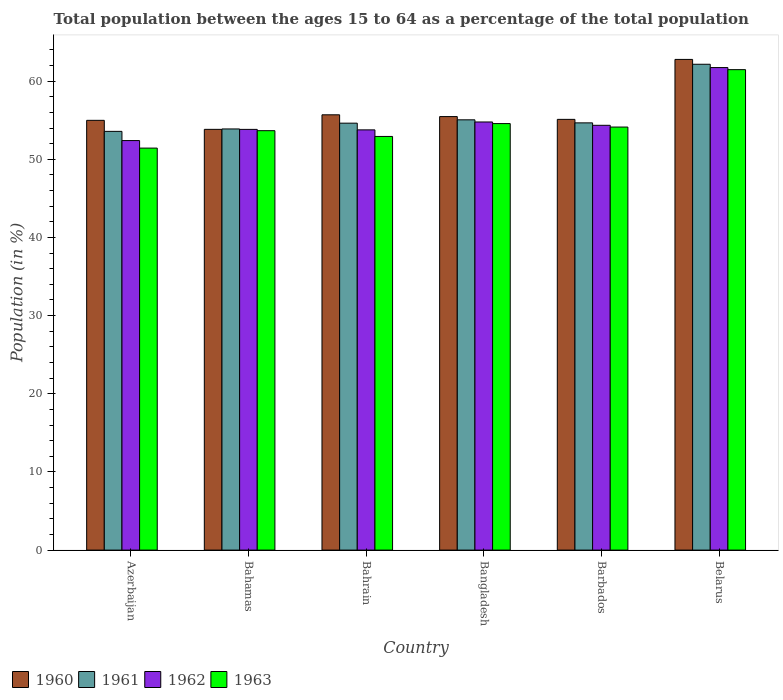How many different coloured bars are there?
Keep it short and to the point. 4. How many groups of bars are there?
Your answer should be compact. 6. How many bars are there on the 5th tick from the right?
Provide a short and direct response. 4. What is the label of the 6th group of bars from the left?
Ensure brevity in your answer.  Belarus. In how many cases, is the number of bars for a given country not equal to the number of legend labels?
Provide a short and direct response. 0. What is the percentage of the population ages 15 to 64 in 1963 in Bahrain?
Give a very brief answer. 52.92. Across all countries, what is the maximum percentage of the population ages 15 to 64 in 1960?
Ensure brevity in your answer.  62.78. Across all countries, what is the minimum percentage of the population ages 15 to 64 in 1962?
Offer a very short reply. 52.4. In which country was the percentage of the population ages 15 to 64 in 1960 maximum?
Offer a very short reply. Belarus. In which country was the percentage of the population ages 15 to 64 in 1960 minimum?
Offer a very short reply. Bahamas. What is the total percentage of the population ages 15 to 64 in 1960 in the graph?
Your response must be concise. 337.86. What is the difference between the percentage of the population ages 15 to 64 in 1962 in Bangladesh and that in Barbados?
Keep it short and to the point. 0.43. What is the difference between the percentage of the population ages 15 to 64 in 1960 in Belarus and the percentage of the population ages 15 to 64 in 1961 in Azerbaijan?
Your response must be concise. 9.21. What is the average percentage of the population ages 15 to 64 in 1962 per country?
Give a very brief answer. 55.14. What is the difference between the percentage of the population ages 15 to 64 of/in 1962 and percentage of the population ages 15 to 64 of/in 1961 in Belarus?
Your response must be concise. -0.42. In how many countries, is the percentage of the population ages 15 to 64 in 1961 greater than 40?
Ensure brevity in your answer.  6. What is the ratio of the percentage of the population ages 15 to 64 in 1961 in Azerbaijan to that in Belarus?
Offer a terse response. 0.86. Is the percentage of the population ages 15 to 64 in 1963 in Bahrain less than that in Belarus?
Your answer should be compact. Yes. Is the difference between the percentage of the population ages 15 to 64 in 1962 in Bahamas and Bahrain greater than the difference between the percentage of the population ages 15 to 64 in 1961 in Bahamas and Bahrain?
Ensure brevity in your answer.  Yes. What is the difference between the highest and the second highest percentage of the population ages 15 to 64 in 1962?
Your answer should be very brief. -7.39. What is the difference between the highest and the lowest percentage of the population ages 15 to 64 in 1963?
Ensure brevity in your answer.  10.04. Is the sum of the percentage of the population ages 15 to 64 in 1960 in Azerbaijan and Bahamas greater than the maximum percentage of the population ages 15 to 64 in 1963 across all countries?
Make the answer very short. Yes. Is it the case that in every country, the sum of the percentage of the population ages 15 to 64 in 1960 and percentage of the population ages 15 to 64 in 1963 is greater than the sum of percentage of the population ages 15 to 64 in 1962 and percentage of the population ages 15 to 64 in 1961?
Offer a very short reply. No. How many bars are there?
Your response must be concise. 24. What is the difference between two consecutive major ticks on the Y-axis?
Make the answer very short. 10. Does the graph contain any zero values?
Offer a terse response. No. How many legend labels are there?
Your response must be concise. 4. What is the title of the graph?
Your answer should be compact. Total population between the ages 15 to 64 as a percentage of the total population. Does "1989" appear as one of the legend labels in the graph?
Your answer should be very brief. No. What is the Population (in %) of 1960 in Azerbaijan?
Make the answer very short. 54.98. What is the Population (in %) in 1961 in Azerbaijan?
Offer a very short reply. 53.57. What is the Population (in %) of 1962 in Azerbaijan?
Give a very brief answer. 52.4. What is the Population (in %) of 1963 in Azerbaijan?
Provide a short and direct response. 51.43. What is the Population (in %) in 1960 in Bahamas?
Give a very brief answer. 53.83. What is the Population (in %) in 1961 in Bahamas?
Keep it short and to the point. 53.88. What is the Population (in %) in 1962 in Bahamas?
Provide a succinct answer. 53.83. What is the Population (in %) of 1963 in Bahamas?
Provide a short and direct response. 53.66. What is the Population (in %) in 1960 in Bahrain?
Offer a terse response. 55.69. What is the Population (in %) in 1961 in Bahrain?
Your answer should be very brief. 54.62. What is the Population (in %) in 1962 in Bahrain?
Make the answer very short. 53.77. What is the Population (in %) of 1963 in Bahrain?
Provide a succinct answer. 52.92. What is the Population (in %) in 1960 in Bangladesh?
Ensure brevity in your answer.  55.46. What is the Population (in %) in 1961 in Bangladesh?
Provide a succinct answer. 55.05. What is the Population (in %) of 1962 in Bangladesh?
Your answer should be very brief. 54.78. What is the Population (in %) of 1963 in Bangladesh?
Ensure brevity in your answer.  54.57. What is the Population (in %) in 1960 in Barbados?
Offer a terse response. 55.11. What is the Population (in %) of 1961 in Barbados?
Offer a terse response. 54.66. What is the Population (in %) in 1962 in Barbados?
Offer a very short reply. 54.35. What is the Population (in %) in 1963 in Barbados?
Provide a succinct answer. 54.12. What is the Population (in %) in 1960 in Belarus?
Your answer should be very brief. 62.78. What is the Population (in %) in 1961 in Belarus?
Ensure brevity in your answer.  62.16. What is the Population (in %) of 1962 in Belarus?
Your answer should be compact. 61.74. What is the Population (in %) in 1963 in Belarus?
Provide a succinct answer. 61.47. Across all countries, what is the maximum Population (in %) of 1960?
Your response must be concise. 62.78. Across all countries, what is the maximum Population (in %) in 1961?
Offer a very short reply. 62.16. Across all countries, what is the maximum Population (in %) in 1962?
Provide a short and direct response. 61.74. Across all countries, what is the maximum Population (in %) in 1963?
Make the answer very short. 61.47. Across all countries, what is the minimum Population (in %) of 1960?
Provide a succinct answer. 53.83. Across all countries, what is the minimum Population (in %) in 1961?
Offer a very short reply. 53.57. Across all countries, what is the minimum Population (in %) of 1962?
Offer a terse response. 52.4. Across all countries, what is the minimum Population (in %) of 1963?
Provide a succinct answer. 51.43. What is the total Population (in %) of 1960 in the graph?
Keep it short and to the point. 337.86. What is the total Population (in %) in 1961 in the graph?
Ensure brevity in your answer.  333.95. What is the total Population (in %) in 1962 in the graph?
Keep it short and to the point. 330.85. What is the total Population (in %) in 1963 in the graph?
Keep it short and to the point. 328.18. What is the difference between the Population (in %) of 1960 in Azerbaijan and that in Bahamas?
Give a very brief answer. 1.15. What is the difference between the Population (in %) of 1961 in Azerbaijan and that in Bahamas?
Provide a succinct answer. -0.31. What is the difference between the Population (in %) in 1962 in Azerbaijan and that in Bahamas?
Give a very brief answer. -1.43. What is the difference between the Population (in %) in 1963 in Azerbaijan and that in Bahamas?
Your answer should be compact. -2.23. What is the difference between the Population (in %) in 1960 in Azerbaijan and that in Bahrain?
Provide a short and direct response. -0.71. What is the difference between the Population (in %) of 1961 in Azerbaijan and that in Bahrain?
Ensure brevity in your answer.  -1.05. What is the difference between the Population (in %) in 1962 in Azerbaijan and that in Bahrain?
Your answer should be compact. -1.37. What is the difference between the Population (in %) in 1963 in Azerbaijan and that in Bahrain?
Keep it short and to the point. -1.49. What is the difference between the Population (in %) of 1960 in Azerbaijan and that in Bangladesh?
Your response must be concise. -0.48. What is the difference between the Population (in %) in 1961 in Azerbaijan and that in Bangladesh?
Make the answer very short. -1.48. What is the difference between the Population (in %) in 1962 in Azerbaijan and that in Bangladesh?
Give a very brief answer. -2.38. What is the difference between the Population (in %) of 1963 in Azerbaijan and that in Bangladesh?
Ensure brevity in your answer.  -3.14. What is the difference between the Population (in %) of 1960 in Azerbaijan and that in Barbados?
Ensure brevity in your answer.  -0.12. What is the difference between the Population (in %) in 1961 in Azerbaijan and that in Barbados?
Provide a short and direct response. -1.09. What is the difference between the Population (in %) of 1962 in Azerbaijan and that in Barbados?
Offer a terse response. -1.95. What is the difference between the Population (in %) of 1963 in Azerbaijan and that in Barbados?
Offer a very short reply. -2.69. What is the difference between the Population (in %) in 1960 in Azerbaijan and that in Belarus?
Provide a succinct answer. -7.79. What is the difference between the Population (in %) in 1961 in Azerbaijan and that in Belarus?
Provide a short and direct response. -8.59. What is the difference between the Population (in %) in 1962 in Azerbaijan and that in Belarus?
Your answer should be very brief. -9.34. What is the difference between the Population (in %) of 1963 in Azerbaijan and that in Belarus?
Offer a very short reply. -10.04. What is the difference between the Population (in %) of 1960 in Bahamas and that in Bahrain?
Give a very brief answer. -1.86. What is the difference between the Population (in %) in 1961 in Bahamas and that in Bahrain?
Keep it short and to the point. -0.74. What is the difference between the Population (in %) of 1962 in Bahamas and that in Bahrain?
Your answer should be compact. 0.06. What is the difference between the Population (in %) of 1963 in Bahamas and that in Bahrain?
Your answer should be very brief. 0.74. What is the difference between the Population (in %) in 1960 in Bahamas and that in Bangladesh?
Provide a succinct answer. -1.63. What is the difference between the Population (in %) of 1961 in Bahamas and that in Bangladesh?
Your response must be concise. -1.17. What is the difference between the Population (in %) in 1962 in Bahamas and that in Bangladesh?
Your answer should be compact. -0.95. What is the difference between the Population (in %) of 1963 in Bahamas and that in Bangladesh?
Your answer should be compact. -0.91. What is the difference between the Population (in %) in 1960 in Bahamas and that in Barbados?
Keep it short and to the point. -1.28. What is the difference between the Population (in %) in 1961 in Bahamas and that in Barbados?
Ensure brevity in your answer.  -0.78. What is the difference between the Population (in %) of 1962 in Bahamas and that in Barbados?
Keep it short and to the point. -0.52. What is the difference between the Population (in %) in 1963 in Bahamas and that in Barbados?
Keep it short and to the point. -0.46. What is the difference between the Population (in %) in 1960 in Bahamas and that in Belarus?
Keep it short and to the point. -8.95. What is the difference between the Population (in %) of 1961 in Bahamas and that in Belarus?
Provide a succinct answer. -8.28. What is the difference between the Population (in %) in 1962 in Bahamas and that in Belarus?
Provide a short and direct response. -7.91. What is the difference between the Population (in %) of 1963 in Bahamas and that in Belarus?
Your answer should be compact. -7.81. What is the difference between the Population (in %) of 1960 in Bahrain and that in Bangladesh?
Make the answer very short. 0.23. What is the difference between the Population (in %) in 1961 in Bahrain and that in Bangladesh?
Keep it short and to the point. -0.43. What is the difference between the Population (in %) in 1962 in Bahrain and that in Bangladesh?
Offer a very short reply. -1.01. What is the difference between the Population (in %) in 1963 in Bahrain and that in Bangladesh?
Offer a very short reply. -1.65. What is the difference between the Population (in %) in 1960 in Bahrain and that in Barbados?
Offer a very short reply. 0.58. What is the difference between the Population (in %) of 1961 in Bahrain and that in Barbados?
Ensure brevity in your answer.  -0.04. What is the difference between the Population (in %) in 1962 in Bahrain and that in Barbados?
Make the answer very short. -0.58. What is the difference between the Population (in %) of 1963 in Bahrain and that in Barbados?
Make the answer very short. -1.2. What is the difference between the Population (in %) in 1960 in Bahrain and that in Belarus?
Offer a very short reply. -7.09. What is the difference between the Population (in %) in 1961 in Bahrain and that in Belarus?
Give a very brief answer. -7.54. What is the difference between the Population (in %) of 1962 in Bahrain and that in Belarus?
Keep it short and to the point. -7.97. What is the difference between the Population (in %) in 1963 in Bahrain and that in Belarus?
Your response must be concise. -8.55. What is the difference between the Population (in %) in 1960 in Bangladesh and that in Barbados?
Your answer should be very brief. 0.36. What is the difference between the Population (in %) of 1961 in Bangladesh and that in Barbados?
Offer a very short reply. 0.39. What is the difference between the Population (in %) of 1962 in Bangladesh and that in Barbados?
Give a very brief answer. 0.43. What is the difference between the Population (in %) of 1963 in Bangladesh and that in Barbados?
Offer a terse response. 0.45. What is the difference between the Population (in %) of 1960 in Bangladesh and that in Belarus?
Offer a terse response. -7.32. What is the difference between the Population (in %) in 1961 in Bangladesh and that in Belarus?
Your answer should be very brief. -7.11. What is the difference between the Population (in %) in 1962 in Bangladesh and that in Belarus?
Your answer should be compact. -6.96. What is the difference between the Population (in %) of 1963 in Bangladesh and that in Belarus?
Your response must be concise. -6.9. What is the difference between the Population (in %) of 1960 in Barbados and that in Belarus?
Your answer should be compact. -7.67. What is the difference between the Population (in %) of 1961 in Barbados and that in Belarus?
Offer a terse response. -7.5. What is the difference between the Population (in %) in 1962 in Barbados and that in Belarus?
Offer a terse response. -7.39. What is the difference between the Population (in %) in 1963 in Barbados and that in Belarus?
Provide a succinct answer. -7.34. What is the difference between the Population (in %) in 1960 in Azerbaijan and the Population (in %) in 1961 in Bahamas?
Your answer should be very brief. 1.1. What is the difference between the Population (in %) of 1960 in Azerbaijan and the Population (in %) of 1962 in Bahamas?
Give a very brief answer. 1.16. What is the difference between the Population (in %) in 1960 in Azerbaijan and the Population (in %) in 1963 in Bahamas?
Your answer should be compact. 1.32. What is the difference between the Population (in %) of 1961 in Azerbaijan and the Population (in %) of 1962 in Bahamas?
Keep it short and to the point. -0.25. What is the difference between the Population (in %) in 1961 in Azerbaijan and the Population (in %) in 1963 in Bahamas?
Offer a very short reply. -0.09. What is the difference between the Population (in %) in 1962 in Azerbaijan and the Population (in %) in 1963 in Bahamas?
Your response must be concise. -1.27. What is the difference between the Population (in %) in 1960 in Azerbaijan and the Population (in %) in 1961 in Bahrain?
Your response must be concise. 0.36. What is the difference between the Population (in %) of 1960 in Azerbaijan and the Population (in %) of 1962 in Bahrain?
Offer a terse response. 1.22. What is the difference between the Population (in %) of 1960 in Azerbaijan and the Population (in %) of 1963 in Bahrain?
Offer a very short reply. 2.06. What is the difference between the Population (in %) of 1961 in Azerbaijan and the Population (in %) of 1962 in Bahrain?
Give a very brief answer. -0.19. What is the difference between the Population (in %) of 1961 in Azerbaijan and the Population (in %) of 1963 in Bahrain?
Your answer should be compact. 0.65. What is the difference between the Population (in %) in 1962 in Azerbaijan and the Population (in %) in 1963 in Bahrain?
Your response must be concise. -0.53. What is the difference between the Population (in %) in 1960 in Azerbaijan and the Population (in %) in 1961 in Bangladesh?
Keep it short and to the point. -0.07. What is the difference between the Population (in %) of 1960 in Azerbaijan and the Population (in %) of 1962 in Bangladesh?
Offer a terse response. 0.21. What is the difference between the Population (in %) in 1960 in Azerbaijan and the Population (in %) in 1963 in Bangladesh?
Your answer should be very brief. 0.41. What is the difference between the Population (in %) in 1961 in Azerbaijan and the Population (in %) in 1962 in Bangladesh?
Keep it short and to the point. -1.2. What is the difference between the Population (in %) in 1961 in Azerbaijan and the Population (in %) in 1963 in Bangladesh?
Ensure brevity in your answer.  -1. What is the difference between the Population (in %) in 1962 in Azerbaijan and the Population (in %) in 1963 in Bangladesh?
Your response must be concise. -2.17. What is the difference between the Population (in %) of 1960 in Azerbaijan and the Population (in %) of 1961 in Barbados?
Your answer should be very brief. 0.32. What is the difference between the Population (in %) in 1960 in Azerbaijan and the Population (in %) in 1962 in Barbados?
Your answer should be compact. 0.64. What is the difference between the Population (in %) of 1960 in Azerbaijan and the Population (in %) of 1963 in Barbados?
Your answer should be compact. 0.86. What is the difference between the Population (in %) in 1961 in Azerbaijan and the Population (in %) in 1962 in Barbados?
Offer a very short reply. -0.78. What is the difference between the Population (in %) in 1961 in Azerbaijan and the Population (in %) in 1963 in Barbados?
Provide a short and direct response. -0.55. What is the difference between the Population (in %) of 1962 in Azerbaijan and the Population (in %) of 1963 in Barbados?
Give a very brief answer. -1.73. What is the difference between the Population (in %) of 1960 in Azerbaijan and the Population (in %) of 1961 in Belarus?
Give a very brief answer. -7.17. What is the difference between the Population (in %) in 1960 in Azerbaijan and the Population (in %) in 1962 in Belarus?
Your answer should be compact. -6.75. What is the difference between the Population (in %) of 1960 in Azerbaijan and the Population (in %) of 1963 in Belarus?
Keep it short and to the point. -6.48. What is the difference between the Population (in %) in 1961 in Azerbaijan and the Population (in %) in 1962 in Belarus?
Provide a short and direct response. -8.16. What is the difference between the Population (in %) in 1961 in Azerbaijan and the Population (in %) in 1963 in Belarus?
Offer a very short reply. -7.9. What is the difference between the Population (in %) in 1962 in Azerbaijan and the Population (in %) in 1963 in Belarus?
Give a very brief answer. -9.07. What is the difference between the Population (in %) in 1960 in Bahamas and the Population (in %) in 1961 in Bahrain?
Provide a short and direct response. -0.79. What is the difference between the Population (in %) of 1960 in Bahamas and the Population (in %) of 1962 in Bahrain?
Give a very brief answer. 0.07. What is the difference between the Population (in %) of 1960 in Bahamas and the Population (in %) of 1963 in Bahrain?
Provide a short and direct response. 0.91. What is the difference between the Population (in %) of 1961 in Bahamas and the Population (in %) of 1962 in Bahrain?
Keep it short and to the point. 0.12. What is the difference between the Population (in %) in 1961 in Bahamas and the Population (in %) in 1963 in Bahrain?
Ensure brevity in your answer.  0.96. What is the difference between the Population (in %) in 1962 in Bahamas and the Population (in %) in 1963 in Bahrain?
Provide a succinct answer. 0.9. What is the difference between the Population (in %) in 1960 in Bahamas and the Population (in %) in 1961 in Bangladesh?
Your answer should be compact. -1.22. What is the difference between the Population (in %) in 1960 in Bahamas and the Population (in %) in 1962 in Bangladesh?
Your answer should be very brief. -0.94. What is the difference between the Population (in %) in 1960 in Bahamas and the Population (in %) in 1963 in Bangladesh?
Your response must be concise. -0.74. What is the difference between the Population (in %) of 1961 in Bahamas and the Population (in %) of 1962 in Bangladesh?
Make the answer very short. -0.89. What is the difference between the Population (in %) in 1961 in Bahamas and the Population (in %) in 1963 in Bangladesh?
Provide a short and direct response. -0.69. What is the difference between the Population (in %) of 1962 in Bahamas and the Population (in %) of 1963 in Bangladesh?
Offer a terse response. -0.74. What is the difference between the Population (in %) of 1960 in Bahamas and the Population (in %) of 1961 in Barbados?
Your answer should be very brief. -0.83. What is the difference between the Population (in %) of 1960 in Bahamas and the Population (in %) of 1962 in Barbados?
Provide a succinct answer. -0.52. What is the difference between the Population (in %) in 1960 in Bahamas and the Population (in %) in 1963 in Barbados?
Your answer should be compact. -0.29. What is the difference between the Population (in %) in 1961 in Bahamas and the Population (in %) in 1962 in Barbados?
Your answer should be compact. -0.46. What is the difference between the Population (in %) of 1961 in Bahamas and the Population (in %) of 1963 in Barbados?
Give a very brief answer. -0.24. What is the difference between the Population (in %) of 1962 in Bahamas and the Population (in %) of 1963 in Barbados?
Provide a succinct answer. -0.3. What is the difference between the Population (in %) in 1960 in Bahamas and the Population (in %) in 1961 in Belarus?
Your answer should be compact. -8.33. What is the difference between the Population (in %) of 1960 in Bahamas and the Population (in %) of 1962 in Belarus?
Offer a very short reply. -7.91. What is the difference between the Population (in %) in 1960 in Bahamas and the Population (in %) in 1963 in Belarus?
Ensure brevity in your answer.  -7.64. What is the difference between the Population (in %) in 1961 in Bahamas and the Population (in %) in 1962 in Belarus?
Offer a terse response. -7.85. What is the difference between the Population (in %) in 1961 in Bahamas and the Population (in %) in 1963 in Belarus?
Offer a terse response. -7.59. What is the difference between the Population (in %) in 1962 in Bahamas and the Population (in %) in 1963 in Belarus?
Your response must be concise. -7.64. What is the difference between the Population (in %) in 1960 in Bahrain and the Population (in %) in 1961 in Bangladesh?
Your answer should be compact. 0.64. What is the difference between the Population (in %) in 1960 in Bahrain and the Population (in %) in 1962 in Bangladesh?
Make the answer very short. 0.92. What is the difference between the Population (in %) of 1960 in Bahrain and the Population (in %) of 1963 in Bangladesh?
Provide a succinct answer. 1.12. What is the difference between the Population (in %) of 1961 in Bahrain and the Population (in %) of 1962 in Bangladesh?
Your answer should be very brief. -0.15. What is the difference between the Population (in %) in 1961 in Bahrain and the Population (in %) in 1963 in Bangladesh?
Ensure brevity in your answer.  0.05. What is the difference between the Population (in %) of 1962 in Bahrain and the Population (in %) of 1963 in Bangladesh?
Keep it short and to the point. -0.8. What is the difference between the Population (in %) in 1960 in Bahrain and the Population (in %) in 1961 in Barbados?
Your response must be concise. 1.03. What is the difference between the Population (in %) of 1960 in Bahrain and the Population (in %) of 1962 in Barbados?
Your answer should be compact. 1.34. What is the difference between the Population (in %) of 1960 in Bahrain and the Population (in %) of 1963 in Barbados?
Your response must be concise. 1.57. What is the difference between the Population (in %) of 1961 in Bahrain and the Population (in %) of 1962 in Barbados?
Provide a succinct answer. 0.27. What is the difference between the Population (in %) of 1961 in Bahrain and the Population (in %) of 1963 in Barbados?
Offer a terse response. 0.5. What is the difference between the Population (in %) in 1962 in Bahrain and the Population (in %) in 1963 in Barbados?
Offer a very short reply. -0.36. What is the difference between the Population (in %) in 1960 in Bahrain and the Population (in %) in 1961 in Belarus?
Your answer should be compact. -6.47. What is the difference between the Population (in %) in 1960 in Bahrain and the Population (in %) in 1962 in Belarus?
Offer a very short reply. -6.04. What is the difference between the Population (in %) of 1960 in Bahrain and the Population (in %) of 1963 in Belarus?
Provide a succinct answer. -5.78. What is the difference between the Population (in %) in 1961 in Bahrain and the Population (in %) in 1962 in Belarus?
Ensure brevity in your answer.  -7.11. What is the difference between the Population (in %) in 1961 in Bahrain and the Population (in %) in 1963 in Belarus?
Your answer should be very brief. -6.85. What is the difference between the Population (in %) in 1962 in Bahrain and the Population (in %) in 1963 in Belarus?
Offer a very short reply. -7.7. What is the difference between the Population (in %) in 1960 in Bangladesh and the Population (in %) in 1961 in Barbados?
Provide a short and direct response. 0.8. What is the difference between the Population (in %) in 1960 in Bangladesh and the Population (in %) in 1962 in Barbados?
Offer a terse response. 1.12. What is the difference between the Population (in %) in 1960 in Bangladesh and the Population (in %) in 1963 in Barbados?
Give a very brief answer. 1.34. What is the difference between the Population (in %) in 1961 in Bangladesh and the Population (in %) in 1962 in Barbados?
Keep it short and to the point. 0.7. What is the difference between the Population (in %) of 1961 in Bangladesh and the Population (in %) of 1963 in Barbados?
Your answer should be very brief. 0.93. What is the difference between the Population (in %) in 1962 in Bangladesh and the Population (in %) in 1963 in Barbados?
Provide a succinct answer. 0.65. What is the difference between the Population (in %) of 1960 in Bangladesh and the Population (in %) of 1961 in Belarus?
Provide a succinct answer. -6.69. What is the difference between the Population (in %) of 1960 in Bangladesh and the Population (in %) of 1962 in Belarus?
Provide a short and direct response. -6.27. What is the difference between the Population (in %) in 1960 in Bangladesh and the Population (in %) in 1963 in Belarus?
Provide a short and direct response. -6. What is the difference between the Population (in %) in 1961 in Bangladesh and the Population (in %) in 1962 in Belarus?
Offer a very short reply. -6.69. What is the difference between the Population (in %) of 1961 in Bangladesh and the Population (in %) of 1963 in Belarus?
Give a very brief answer. -6.42. What is the difference between the Population (in %) of 1962 in Bangladesh and the Population (in %) of 1963 in Belarus?
Your response must be concise. -6.69. What is the difference between the Population (in %) of 1960 in Barbados and the Population (in %) of 1961 in Belarus?
Ensure brevity in your answer.  -7.05. What is the difference between the Population (in %) in 1960 in Barbados and the Population (in %) in 1962 in Belarus?
Provide a short and direct response. -6.63. What is the difference between the Population (in %) of 1960 in Barbados and the Population (in %) of 1963 in Belarus?
Provide a succinct answer. -6.36. What is the difference between the Population (in %) of 1961 in Barbados and the Population (in %) of 1962 in Belarus?
Keep it short and to the point. -7.07. What is the difference between the Population (in %) in 1961 in Barbados and the Population (in %) in 1963 in Belarus?
Offer a very short reply. -6.81. What is the difference between the Population (in %) in 1962 in Barbados and the Population (in %) in 1963 in Belarus?
Your answer should be very brief. -7.12. What is the average Population (in %) in 1960 per country?
Give a very brief answer. 56.31. What is the average Population (in %) of 1961 per country?
Give a very brief answer. 55.66. What is the average Population (in %) of 1962 per country?
Keep it short and to the point. 55.14. What is the average Population (in %) of 1963 per country?
Your response must be concise. 54.7. What is the difference between the Population (in %) of 1960 and Population (in %) of 1961 in Azerbaijan?
Make the answer very short. 1.41. What is the difference between the Population (in %) in 1960 and Population (in %) in 1962 in Azerbaijan?
Make the answer very short. 2.59. What is the difference between the Population (in %) in 1960 and Population (in %) in 1963 in Azerbaijan?
Offer a very short reply. 3.55. What is the difference between the Population (in %) in 1961 and Population (in %) in 1962 in Azerbaijan?
Provide a succinct answer. 1.18. What is the difference between the Population (in %) in 1961 and Population (in %) in 1963 in Azerbaijan?
Give a very brief answer. 2.14. What is the difference between the Population (in %) of 1962 and Population (in %) of 1963 in Azerbaijan?
Your answer should be very brief. 0.96. What is the difference between the Population (in %) in 1960 and Population (in %) in 1961 in Bahamas?
Make the answer very short. -0.05. What is the difference between the Population (in %) in 1960 and Population (in %) in 1962 in Bahamas?
Ensure brevity in your answer.  0. What is the difference between the Population (in %) in 1960 and Population (in %) in 1963 in Bahamas?
Your answer should be very brief. 0.17. What is the difference between the Population (in %) of 1961 and Population (in %) of 1962 in Bahamas?
Keep it short and to the point. 0.06. What is the difference between the Population (in %) of 1961 and Population (in %) of 1963 in Bahamas?
Provide a short and direct response. 0.22. What is the difference between the Population (in %) of 1962 and Population (in %) of 1963 in Bahamas?
Your answer should be very brief. 0.17. What is the difference between the Population (in %) in 1960 and Population (in %) in 1961 in Bahrain?
Make the answer very short. 1.07. What is the difference between the Population (in %) of 1960 and Population (in %) of 1962 in Bahrain?
Provide a short and direct response. 1.93. What is the difference between the Population (in %) in 1960 and Population (in %) in 1963 in Bahrain?
Offer a terse response. 2.77. What is the difference between the Population (in %) in 1961 and Population (in %) in 1962 in Bahrain?
Your response must be concise. 0.86. What is the difference between the Population (in %) in 1961 and Population (in %) in 1963 in Bahrain?
Make the answer very short. 1.7. What is the difference between the Population (in %) in 1962 and Population (in %) in 1963 in Bahrain?
Keep it short and to the point. 0.84. What is the difference between the Population (in %) in 1960 and Population (in %) in 1961 in Bangladesh?
Provide a short and direct response. 0.41. What is the difference between the Population (in %) of 1960 and Population (in %) of 1962 in Bangladesh?
Make the answer very short. 0.69. What is the difference between the Population (in %) of 1960 and Population (in %) of 1963 in Bangladesh?
Give a very brief answer. 0.89. What is the difference between the Population (in %) in 1961 and Population (in %) in 1962 in Bangladesh?
Provide a succinct answer. 0.28. What is the difference between the Population (in %) in 1961 and Population (in %) in 1963 in Bangladesh?
Provide a short and direct response. 0.48. What is the difference between the Population (in %) of 1962 and Population (in %) of 1963 in Bangladesh?
Make the answer very short. 0.21. What is the difference between the Population (in %) in 1960 and Population (in %) in 1961 in Barbados?
Provide a succinct answer. 0.45. What is the difference between the Population (in %) in 1960 and Population (in %) in 1962 in Barbados?
Your answer should be very brief. 0.76. What is the difference between the Population (in %) in 1960 and Population (in %) in 1963 in Barbados?
Offer a very short reply. 0.98. What is the difference between the Population (in %) in 1961 and Population (in %) in 1962 in Barbados?
Provide a short and direct response. 0.31. What is the difference between the Population (in %) of 1961 and Population (in %) of 1963 in Barbados?
Make the answer very short. 0.54. What is the difference between the Population (in %) in 1962 and Population (in %) in 1963 in Barbados?
Your answer should be very brief. 0.22. What is the difference between the Population (in %) of 1960 and Population (in %) of 1961 in Belarus?
Ensure brevity in your answer.  0.62. What is the difference between the Population (in %) in 1960 and Population (in %) in 1962 in Belarus?
Keep it short and to the point. 1.04. What is the difference between the Population (in %) of 1960 and Population (in %) of 1963 in Belarus?
Your answer should be very brief. 1.31. What is the difference between the Population (in %) of 1961 and Population (in %) of 1962 in Belarus?
Ensure brevity in your answer.  0.42. What is the difference between the Population (in %) in 1961 and Population (in %) in 1963 in Belarus?
Keep it short and to the point. 0.69. What is the difference between the Population (in %) in 1962 and Population (in %) in 1963 in Belarus?
Your answer should be very brief. 0.27. What is the ratio of the Population (in %) of 1960 in Azerbaijan to that in Bahamas?
Give a very brief answer. 1.02. What is the ratio of the Population (in %) in 1962 in Azerbaijan to that in Bahamas?
Your response must be concise. 0.97. What is the ratio of the Population (in %) in 1963 in Azerbaijan to that in Bahamas?
Offer a terse response. 0.96. What is the ratio of the Population (in %) in 1960 in Azerbaijan to that in Bahrain?
Make the answer very short. 0.99. What is the ratio of the Population (in %) in 1961 in Azerbaijan to that in Bahrain?
Your response must be concise. 0.98. What is the ratio of the Population (in %) of 1962 in Azerbaijan to that in Bahrain?
Provide a short and direct response. 0.97. What is the ratio of the Population (in %) of 1963 in Azerbaijan to that in Bahrain?
Provide a succinct answer. 0.97. What is the ratio of the Population (in %) in 1961 in Azerbaijan to that in Bangladesh?
Offer a very short reply. 0.97. What is the ratio of the Population (in %) of 1962 in Azerbaijan to that in Bangladesh?
Keep it short and to the point. 0.96. What is the ratio of the Population (in %) in 1963 in Azerbaijan to that in Bangladesh?
Your answer should be very brief. 0.94. What is the ratio of the Population (in %) in 1961 in Azerbaijan to that in Barbados?
Give a very brief answer. 0.98. What is the ratio of the Population (in %) of 1962 in Azerbaijan to that in Barbados?
Your answer should be compact. 0.96. What is the ratio of the Population (in %) of 1963 in Azerbaijan to that in Barbados?
Provide a short and direct response. 0.95. What is the ratio of the Population (in %) in 1960 in Azerbaijan to that in Belarus?
Provide a succinct answer. 0.88. What is the ratio of the Population (in %) in 1961 in Azerbaijan to that in Belarus?
Give a very brief answer. 0.86. What is the ratio of the Population (in %) in 1962 in Azerbaijan to that in Belarus?
Your response must be concise. 0.85. What is the ratio of the Population (in %) of 1963 in Azerbaijan to that in Belarus?
Provide a succinct answer. 0.84. What is the ratio of the Population (in %) of 1960 in Bahamas to that in Bahrain?
Give a very brief answer. 0.97. What is the ratio of the Population (in %) in 1961 in Bahamas to that in Bahrain?
Offer a very short reply. 0.99. What is the ratio of the Population (in %) of 1962 in Bahamas to that in Bahrain?
Offer a terse response. 1. What is the ratio of the Population (in %) in 1960 in Bahamas to that in Bangladesh?
Your answer should be compact. 0.97. What is the ratio of the Population (in %) of 1961 in Bahamas to that in Bangladesh?
Keep it short and to the point. 0.98. What is the ratio of the Population (in %) in 1962 in Bahamas to that in Bangladesh?
Your answer should be very brief. 0.98. What is the ratio of the Population (in %) of 1963 in Bahamas to that in Bangladesh?
Make the answer very short. 0.98. What is the ratio of the Population (in %) in 1960 in Bahamas to that in Barbados?
Keep it short and to the point. 0.98. What is the ratio of the Population (in %) of 1961 in Bahamas to that in Barbados?
Your response must be concise. 0.99. What is the ratio of the Population (in %) of 1962 in Bahamas to that in Barbados?
Give a very brief answer. 0.99. What is the ratio of the Population (in %) of 1960 in Bahamas to that in Belarus?
Ensure brevity in your answer.  0.86. What is the ratio of the Population (in %) of 1961 in Bahamas to that in Belarus?
Give a very brief answer. 0.87. What is the ratio of the Population (in %) in 1962 in Bahamas to that in Belarus?
Give a very brief answer. 0.87. What is the ratio of the Population (in %) of 1963 in Bahamas to that in Belarus?
Make the answer very short. 0.87. What is the ratio of the Population (in %) in 1960 in Bahrain to that in Bangladesh?
Provide a succinct answer. 1. What is the ratio of the Population (in %) of 1961 in Bahrain to that in Bangladesh?
Your answer should be compact. 0.99. What is the ratio of the Population (in %) of 1962 in Bahrain to that in Bangladesh?
Provide a succinct answer. 0.98. What is the ratio of the Population (in %) in 1963 in Bahrain to that in Bangladesh?
Give a very brief answer. 0.97. What is the ratio of the Population (in %) of 1960 in Bahrain to that in Barbados?
Your answer should be very brief. 1.01. What is the ratio of the Population (in %) in 1962 in Bahrain to that in Barbados?
Your answer should be very brief. 0.99. What is the ratio of the Population (in %) of 1963 in Bahrain to that in Barbados?
Give a very brief answer. 0.98. What is the ratio of the Population (in %) of 1960 in Bahrain to that in Belarus?
Your answer should be compact. 0.89. What is the ratio of the Population (in %) of 1961 in Bahrain to that in Belarus?
Ensure brevity in your answer.  0.88. What is the ratio of the Population (in %) of 1962 in Bahrain to that in Belarus?
Ensure brevity in your answer.  0.87. What is the ratio of the Population (in %) in 1963 in Bahrain to that in Belarus?
Offer a terse response. 0.86. What is the ratio of the Population (in %) of 1961 in Bangladesh to that in Barbados?
Provide a succinct answer. 1.01. What is the ratio of the Population (in %) in 1962 in Bangladesh to that in Barbados?
Your response must be concise. 1.01. What is the ratio of the Population (in %) of 1963 in Bangladesh to that in Barbados?
Keep it short and to the point. 1.01. What is the ratio of the Population (in %) in 1960 in Bangladesh to that in Belarus?
Give a very brief answer. 0.88. What is the ratio of the Population (in %) in 1961 in Bangladesh to that in Belarus?
Offer a very short reply. 0.89. What is the ratio of the Population (in %) of 1962 in Bangladesh to that in Belarus?
Offer a terse response. 0.89. What is the ratio of the Population (in %) in 1963 in Bangladesh to that in Belarus?
Offer a terse response. 0.89. What is the ratio of the Population (in %) of 1960 in Barbados to that in Belarus?
Offer a very short reply. 0.88. What is the ratio of the Population (in %) in 1961 in Barbados to that in Belarus?
Your answer should be very brief. 0.88. What is the ratio of the Population (in %) in 1962 in Barbados to that in Belarus?
Ensure brevity in your answer.  0.88. What is the ratio of the Population (in %) in 1963 in Barbados to that in Belarus?
Your response must be concise. 0.88. What is the difference between the highest and the second highest Population (in %) in 1960?
Give a very brief answer. 7.09. What is the difference between the highest and the second highest Population (in %) of 1961?
Offer a terse response. 7.11. What is the difference between the highest and the second highest Population (in %) of 1962?
Provide a succinct answer. 6.96. What is the difference between the highest and the second highest Population (in %) in 1963?
Give a very brief answer. 6.9. What is the difference between the highest and the lowest Population (in %) in 1960?
Your response must be concise. 8.95. What is the difference between the highest and the lowest Population (in %) of 1961?
Your answer should be very brief. 8.59. What is the difference between the highest and the lowest Population (in %) of 1962?
Offer a very short reply. 9.34. What is the difference between the highest and the lowest Population (in %) in 1963?
Provide a short and direct response. 10.04. 